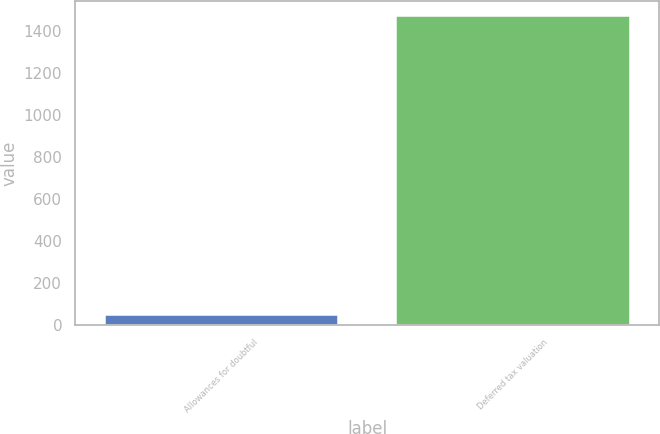Convert chart. <chart><loc_0><loc_0><loc_500><loc_500><bar_chart><fcel>Allowances for doubtful<fcel>Deferred tax valuation<nl><fcel>46<fcel>1468<nl></chart> 